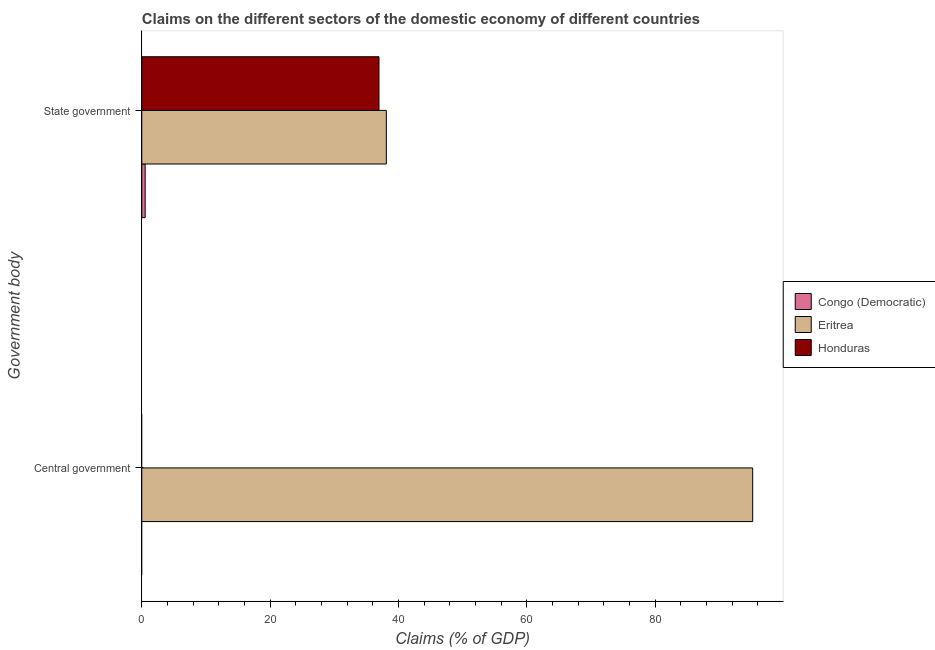Are the number of bars per tick equal to the number of legend labels?
Offer a very short reply. No. How many bars are there on the 2nd tick from the top?
Offer a terse response. 1. What is the label of the 2nd group of bars from the top?
Provide a short and direct response. Central government. Across all countries, what is the maximum claims on central government?
Your response must be concise. 95.2. Across all countries, what is the minimum claims on state government?
Provide a succinct answer. 0.52. In which country was the claims on central government maximum?
Provide a short and direct response. Eritrea. What is the total claims on central government in the graph?
Give a very brief answer. 95.2. What is the difference between the claims on state government in Honduras and that in Eritrea?
Your response must be concise. -1.15. What is the difference between the claims on central government in Honduras and the claims on state government in Congo (Democratic)?
Keep it short and to the point. -0.52. What is the average claims on state government per country?
Give a very brief answer. 25.2. What is the difference between the claims on state government and claims on central government in Eritrea?
Your answer should be compact. -57.09. What is the ratio of the claims on state government in Congo (Democratic) to that in Eritrea?
Offer a terse response. 0.01. How many bars are there?
Make the answer very short. 4. Are all the bars in the graph horizontal?
Give a very brief answer. Yes. Are the values on the major ticks of X-axis written in scientific E-notation?
Give a very brief answer. No. Does the graph contain grids?
Your answer should be compact. No. How are the legend labels stacked?
Give a very brief answer. Vertical. What is the title of the graph?
Offer a terse response. Claims on the different sectors of the domestic economy of different countries. Does "Papua New Guinea" appear as one of the legend labels in the graph?
Make the answer very short. No. What is the label or title of the X-axis?
Your answer should be very brief. Claims (% of GDP). What is the label or title of the Y-axis?
Ensure brevity in your answer.  Government body. What is the Claims (% of GDP) in Congo (Democratic) in Central government?
Keep it short and to the point. 0. What is the Claims (% of GDP) in Eritrea in Central government?
Offer a terse response. 95.2. What is the Claims (% of GDP) in Congo (Democratic) in State government?
Ensure brevity in your answer.  0.52. What is the Claims (% of GDP) of Eritrea in State government?
Provide a succinct answer. 38.11. What is the Claims (% of GDP) of Honduras in State government?
Keep it short and to the point. 36.96. Across all Government body, what is the maximum Claims (% of GDP) of Congo (Democratic)?
Give a very brief answer. 0.52. Across all Government body, what is the maximum Claims (% of GDP) of Eritrea?
Give a very brief answer. 95.2. Across all Government body, what is the maximum Claims (% of GDP) in Honduras?
Make the answer very short. 36.96. Across all Government body, what is the minimum Claims (% of GDP) in Congo (Democratic)?
Offer a terse response. 0. Across all Government body, what is the minimum Claims (% of GDP) in Eritrea?
Offer a terse response. 38.11. Across all Government body, what is the minimum Claims (% of GDP) of Honduras?
Offer a very short reply. 0. What is the total Claims (% of GDP) of Congo (Democratic) in the graph?
Make the answer very short. 0.52. What is the total Claims (% of GDP) of Eritrea in the graph?
Keep it short and to the point. 133.31. What is the total Claims (% of GDP) in Honduras in the graph?
Keep it short and to the point. 36.96. What is the difference between the Claims (% of GDP) in Eritrea in Central government and that in State government?
Provide a succinct answer. 57.09. What is the difference between the Claims (% of GDP) in Eritrea in Central government and the Claims (% of GDP) in Honduras in State government?
Keep it short and to the point. 58.23. What is the average Claims (% of GDP) in Congo (Democratic) per Government body?
Ensure brevity in your answer.  0.26. What is the average Claims (% of GDP) of Eritrea per Government body?
Ensure brevity in your answer.  66.65. What is the average Claims (% of GDP) in Honduras per Government body?
Provide a succinct answer. 18.48. What is the difference between the Claims (% of GDP) of Congo (Democratic) and Claims (% of GDP) of Eritrea in State government?
Provide a short and direct response. -37.59. What is the difference between the Claims (% of GDP) of Congo (Democratic) and Claims (% of GDP) of Honduras in State government?
Offer a terse response. -36.44. What is the difference between the Claims (% of GDP) of Eritrea and Claims (% of GDP) of Honduras in State government?
Provide a short and direct response. 1.15. What is the ratio of the Claims (% of GDP) in Eritrea in Central government to that in State government?
Your answer should be compact. 2.5. What is the difference between the highest and the second highest Claims (% of GDP) in Eritrea?
Keep it short and to the point. 57.09. What is the difference between the highest and the lowest Claims (% of GDP) of Congo (Democratic)?
Give a very brief answer. 0.52. What is the difference between the highest and the lowest Claims (% of GDP) in Eritrea?
Your answer should be very brief. 57.09. What is the difference between the highest and the lowest Claims (% of GDP) of Honduras?
Your answer should be compact. 36.96. 